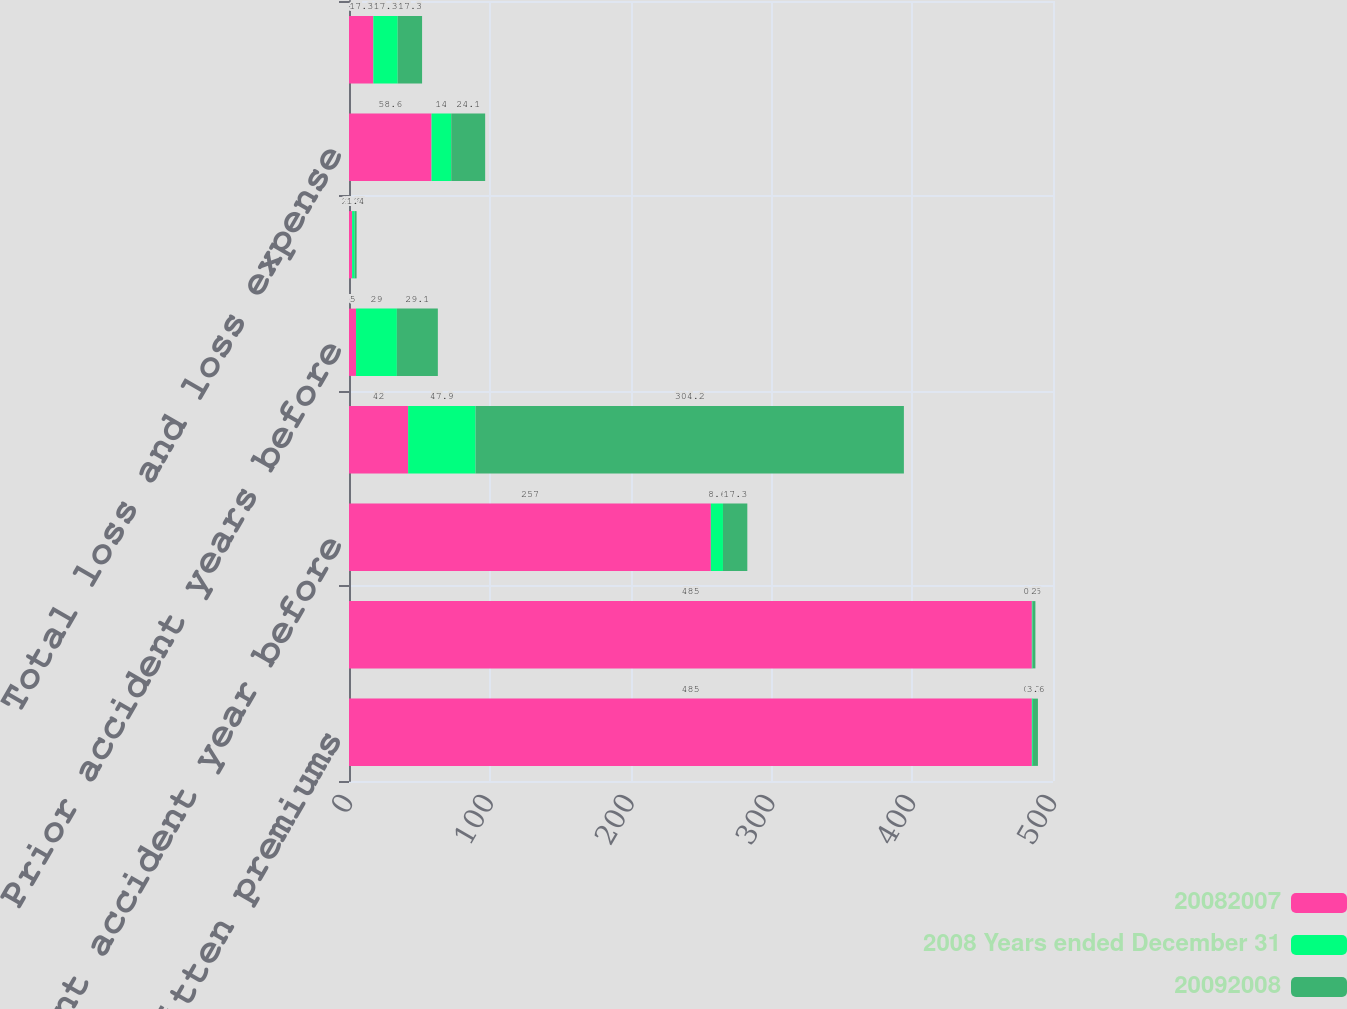<chart> <loc_0><loc_0><loc_500><loc_500><stacked_bar_chart><ecel><fcel>Written premiums<fcel>Earned premiums<fcel>Current accident year before<fcel>Current accident year<fcel>Prior accident years before<fcel>Prior accident year<fcel>Total loss and loss expense<fcel>Accident Year<nl><fcel>20082007<fcel>485<fcel>485<fcel>257<fcel>42<fcel>5<fcel>2.2<fcel>58.6<fcel>17.3<nl><fcel>2008 Years ended December 31<fcel>0.7<fcel>0.5<fcel>8.6<fcel>47.9<fcel>29<fcel>1.8<fcel>14<fcel>17.3<nl><fcel>20092008<fcel>3.6<fcel>2<fcel>17.3<fcel>304.2<fcel>29.1<fcel>1.4<fcel>24.1<fcel>17.3<nl></chart> 